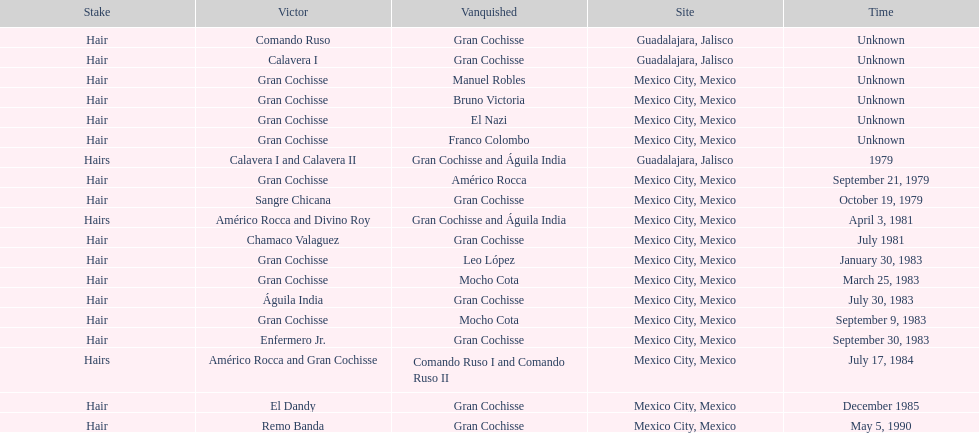How many winners were there before bruno victoria lost? 3. 